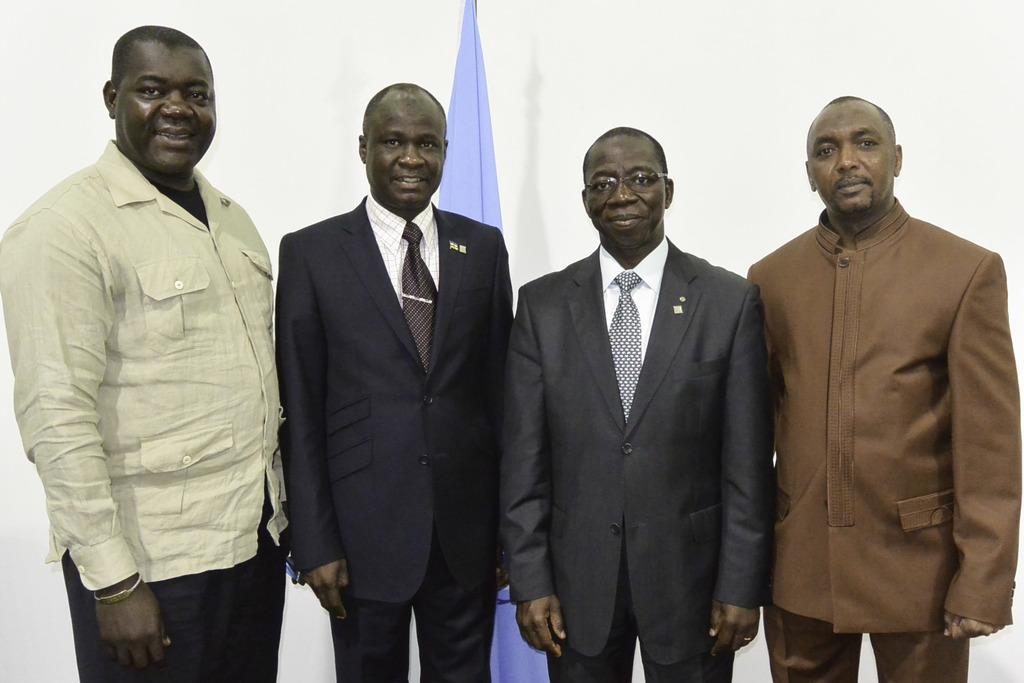Could you give a brief overview of what you see in this image? In this image I can see see a group of people. In the background, I can see some cloth. 